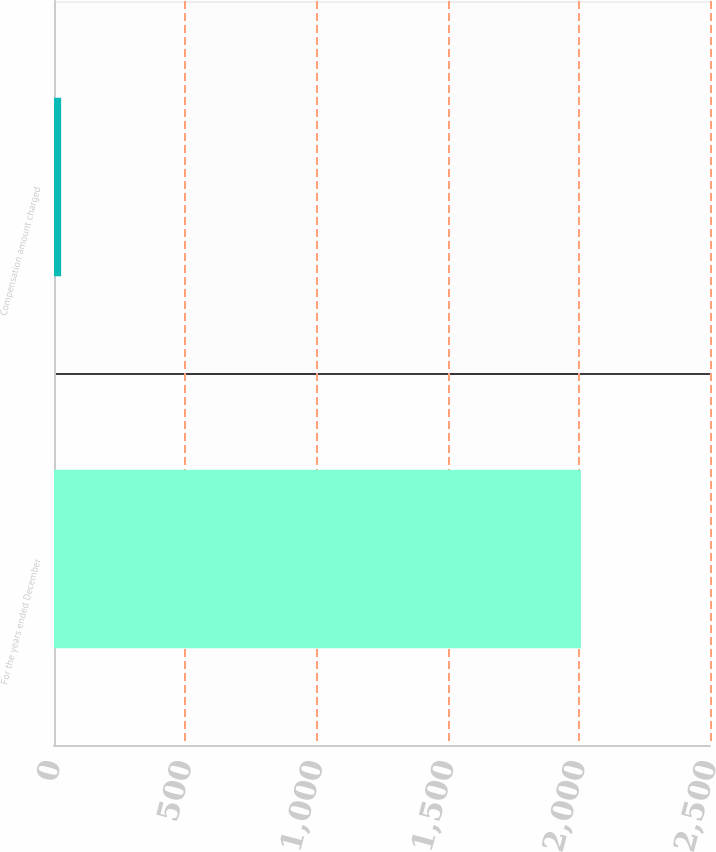Convert chart. <chart><loc_0><loc_0><loc_500><loc_500><bar_chart><fcel>For the years ended December<fcel>Compensation amount charged<nl><fcel>2008<fcel>27.2<nl></chart> 